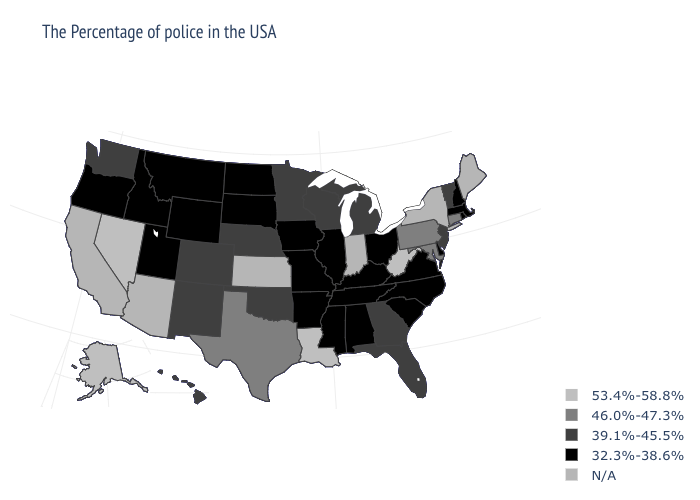Is the legend a continuous bar?
Short answer required. No. What is the value of Ohio?
Quick response, please. 32.3%-38.6%. Which states have the lowest value in the South?
Give a very brief answer. Delaware, Virginia, North Carolina, South Carolina, Kentucky, Alabama, Tennessee, Mississippi, Arkansas. Does the first symbol in the legend represent the smallest category?
Give a very brief answer. No. What is the value of Utah?
Write a very short answer. 32.3%-38.6%. What is the value of Utah?
Give a very brief answer. 32.3%-38.6%. What is the value of Tennessee?
Short answer required. 32.3%-38.6%. Name the states that have a value in the range 32.3%-38.6%?
Short answer required. Massachusetts, Rhode Island, New Hampshire, Delaware, Virginia, North Carolina, South Carolina, Ohio, Kentucky, Alabama, Tennessee, Illinois, Mississippi, Missouri, Arkansas, Iowa, South Dakota, North Dakota, Wyoming, Utah, Montana, Idaho, Oregon. Does Pennsylvania have the lowest value in the Northeast?
Answer briefly. No. Name the states that have a value in the range 39.1%-45.5%?
Keep it brief. Vermont, New Jersey, Florida, Georgia, Michigan, Wisconsin, Minnesota, Nebraska, Oklahoma, Colorado, New Mexico, Washington, Hawaii. Which states hav the highest value in the South?
Answer briefly. West Virginia, Louisiana. What is the value of Nevada?
Keep it brief. 53.4%-58.8%. 